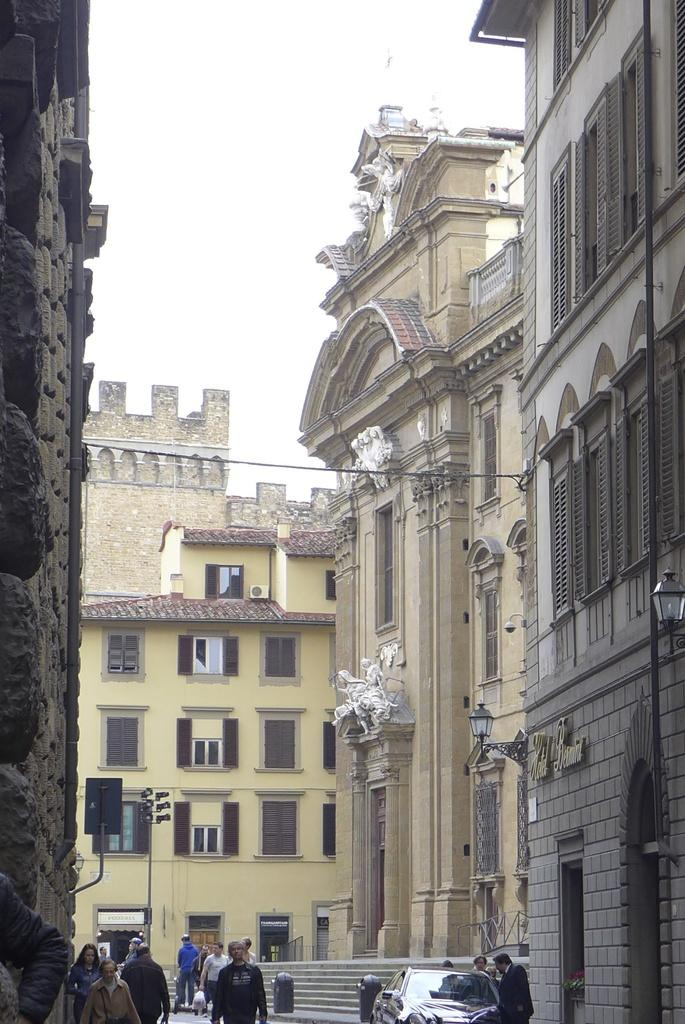How many people are in the image? There is a group of people in the image, but the exact number cannot be determined from the provided facts. What is the main mode of transportation in the image? There is a car in the image, which is a common mode of transportation. What architectural feature is present in the image? There are steps in the image. What type of structures are visible in the image? There are buildings with windows in the image. Can you describe any other objects in the image? The provided facts mention that there are some objects in the image, but their specific nature cannot be determined. What can be seen in the background of the image? The sky is visible in the background of the image. What type of plastic material is used to make the relation between the people in the image? There is no plastic material or relation between the people mentioned in the image. The provided facts only mention a group of people and do not specify any connections or interactions between them. 